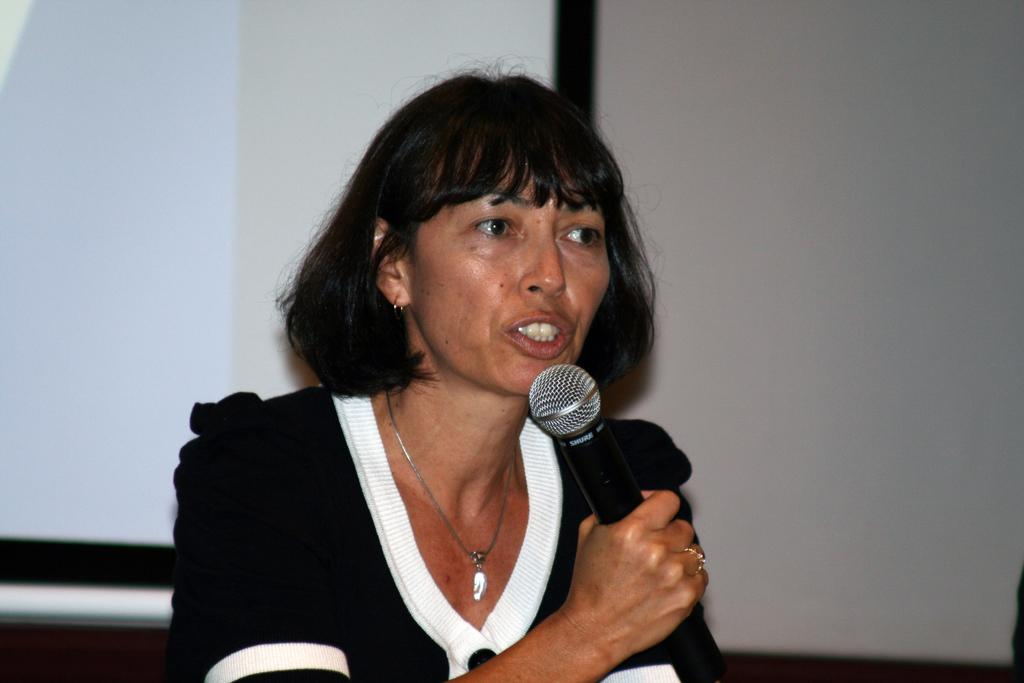Who or what is present in the image? There is a person in the image. What is the person holding in the image? The person is holding a microphone. What can be seen behind the person in the image? There is a white-colored wall in the background of the image. How many goldfish are swimming in the image? There are no goldfish present in the image. What type of sock is the person wearing in the image? The image does not show the person's feet or any socks. 